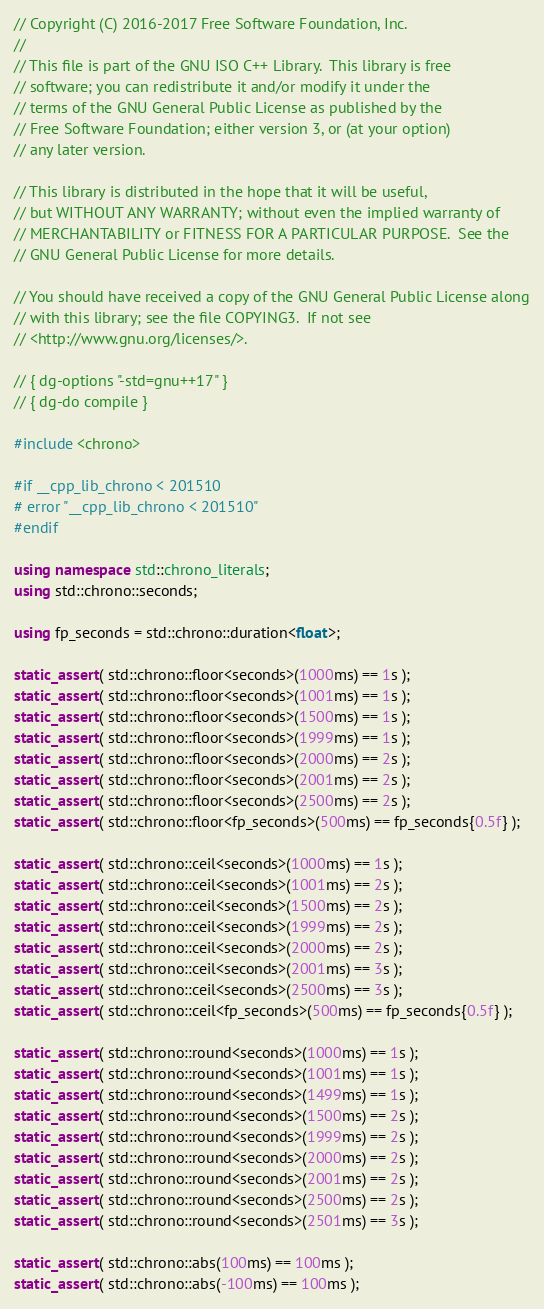<code> <loc_0><loc_0><loc_500><loc_500><_C++_>// Copyright (C) 2016-2017 Free Software Foundation, Inc.
//
// This file is part of the GNU ISO C++ Library.  This library is free
// software; you can redistribute it and/or modify it under the
// terms of the GNU General Public License as published by the
// Free Software Foundation; either version 3, or (at your option)
// any later version.

// This library is distributed in the hope that it will be useful,
// but WITHOUT ANY WARRANTY; without even the implied warranty of
// MERCHANTABILITY or FITNESS FOR A PARTICULAR PURPOSE.  See the
// GNU General Public License for more details.

// You should have received a copy of the GNU General Public License along
// with this library; see the file COPYING3.  If not see
// <http://www.gnu.org/licenses/>.

// { dg-options "-std=gnu++17" }
// { dg-do compile }

#include <chrono>

#if __cpp_lib_chrono < 201510
# error "__cpp_lib_chrono < 201510"
#endif

using namespace std::chrono_literals;
using std::chrono::seconds;

using fp_seconds = std::chrono::duration<float>;

static_assert( std::chrono::floor<seconds>(1000ms) == 1s );
static_assert( std::chrono::floor<seconds>(1001ms) == 1s );
static_assert( std::chrono::floor<seconds>(1500ms) == 1s );
static_assert( std::chrono::floor<seconds>(1999ms) == 1s );
static_assert( std::chrono::floor<seconds>(2000ms) == 2s );
static_assert( std::chrono::floor<seconds>(2001ms) == 2s );
static_assert( std::chrono::floor<seconds>(2500ms) == 2s );
static_assert( std::chrono::floor<fp_seconds>(500ms) == fp_seconds{0.5f} );

static_assert( std::chrono::ceil<seconds>(1000ms) == 1s );
static_assert( std::chrono::ceil<seconds>(1001ms) == 2s );
static_assert( std::chrono::ceil<seconds>(1500ms) == 2s );
static_assert( std::chrono::ceil<seconds>(1999ms) == 2s );
static_assert( std::chrono::ceil<seconds>(2000ms) == 2s );
static_assert( std::chrono::ceil<seconds>(2001ms) == 3s );
static_assert( std::chrono::ceil<seconds>(2500ms) == 3s );
static_assert( std::chrono::ceil<fp_seconds>(500ms) == fp_seconds{0.5f} );

static_assert( std::chrono::round<seconds>(1000ms) == 1s );
static_assert( std::chrono::round<seconds>(1001ms) == 1s );
static_assert( std::chrono::round<seconds>(1499ms) == 1s );
static_assert( std::chrono::round<seconds>(1500ms) == 2s );
static_assert( std::chrono::round<seconds>(1999ms) == 2s );
static_assert( std::chrono::round<seconds>(2000ms) == 2s );
static_assert( std::chrono::round<seconds>(2001ms) == 2s );
static_assert( std::chrono::round<seconds>(2500ms) == 2s );
static_assert( std::chrono::round<seconds>(2501ms) == 3s );

static_assert( std::chrono::abs(100ms) == 100ms );
static_assert( std::chrono::abs(-100ms) == 100ms );
</code> 